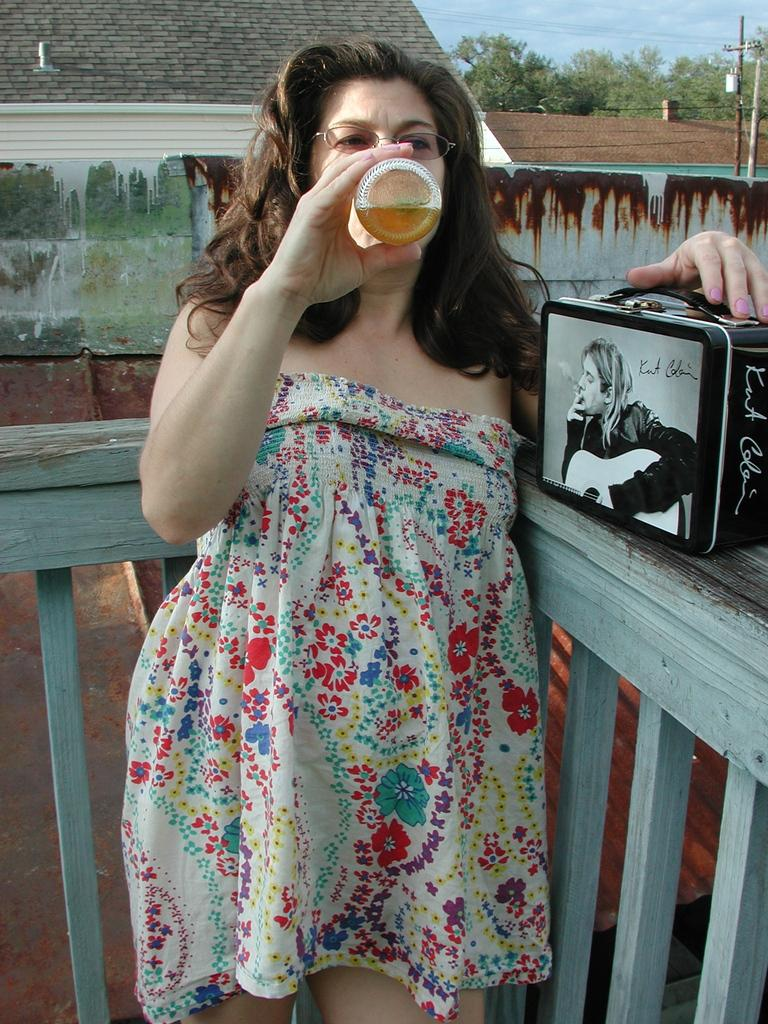Who is present in the image? There is a woman in the image. What can be seen in the background of the image? There is a roof, trees, and the sky visible in the background of the image. What type of coil is being used by the woman in the image? There is no coil present in the image. What is the purpose of the woman's journey in the image? There is no journey depicted in the image; it simply shows a woman and the background elements. 